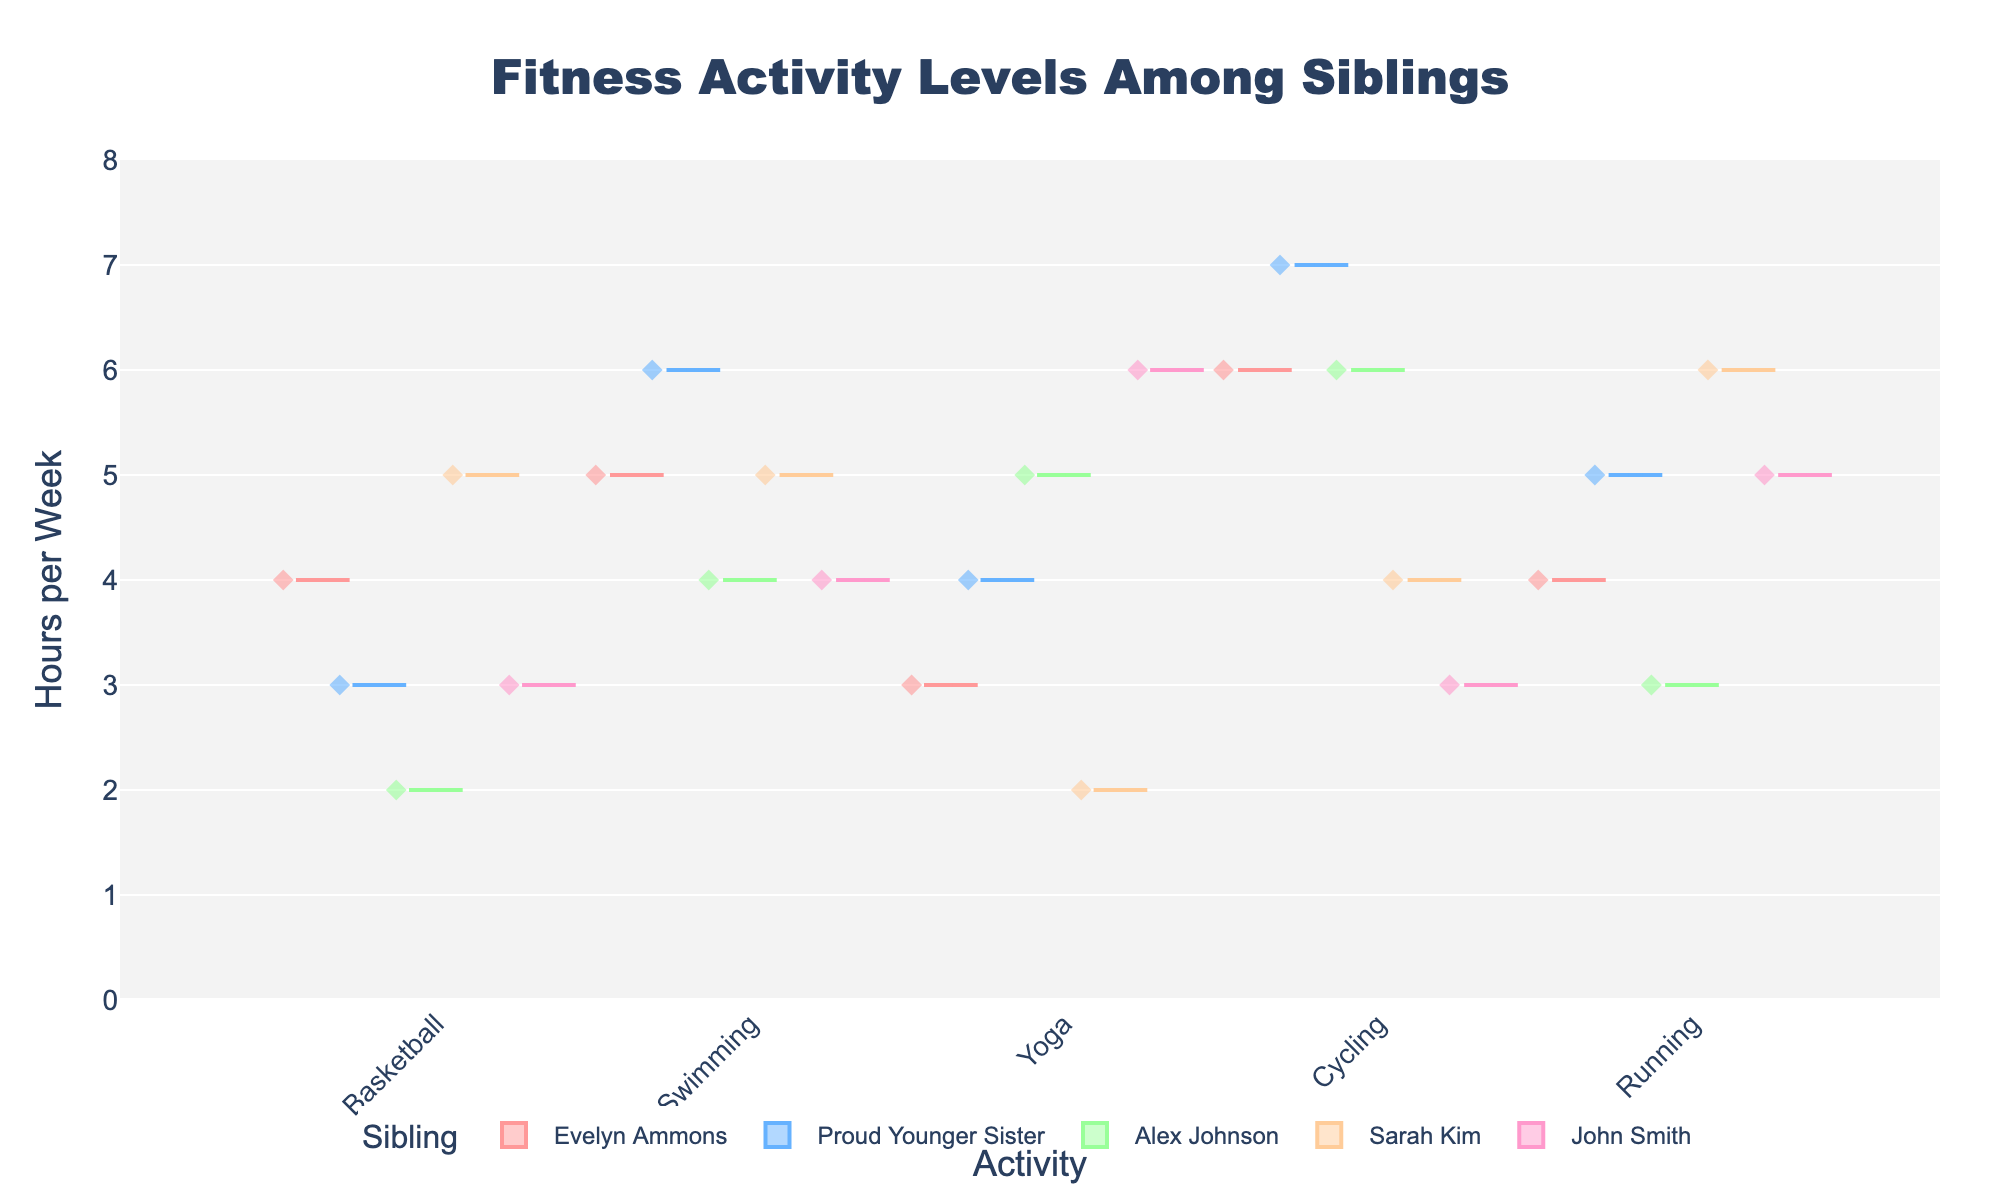Which sibling recorded the highest number of hours per week in Cycling? Look at the Violin Chart and identify the sibling with the longest specific plot for Cycling in hours per week. Proud Younger Sister has 7 hours of Cycling per week, which is the highest in the chart.
Answer: Proud Younger Sister How many hours per week does Evelyn spend on Swimming? Locate Evelyn Ammons on the violin plot under the Swimming category. She is shown to contribute 5 hours per week.
Answer: 5 Which activity did John Smith spend the least hours on per week? Check John Smith's data points for the minimum value across all activities: Basketball (3), Swimming (4), Yoga (6), Cycling (3), and Running (5). Cycling and Basketball both have 3 hours, the smallest number.
Answer: Cycling and Basketball What’s the range of hours per week that Alex Johnson spends on activities? Review the maximum and minimum hours Alex Johnson spent on various activities: 2 to 6 hours per week (the minimum is for Basketball and the maximum for Cycling and Swimming). The range is 6 - 2 = 4.
Answer: 4 Which two siblings have the same maximum hours per week for any activity, and what is that activity? Compare the maximum hours spent on a single activity for each sibling. Both John Smith and Alex Johnson have their maximum at 6 hours in Yoga and Cycling respectively.
Answer: John Smith, Alex Johnson, Yoga, Cycling Among all siblings, who has the highest overall hours per week in Running? Look at the Running category in the figure and check which sibling has the highest hours. Sarah Kim leads with 6 hours per week.
Answer: Sarah Kim Compare the median hours per week Evelyn and Proud Younger Sister spend on Basketball. Review the box plots for Evelyn Ammons and Proud Younger Sister under the Basketball section; the median for Evelyn Ammons is 4 and for Proud Younger Sister is 3.
Answer: Evelyn Ammons's median is higher Which activity shows the most variation for Sarah Kim? For Sarah Kim, look at the spread width of each violin plot and find the one with the largest spread. Yoga shows the most variation with hours spanning from 2 upwards.
Answer: Yoga In which activity is the average number of hours per week the same for both Evelyn Ammons and John Smith? Look at the mean lines in the box plot for various activities for both Evelyn Ammons and John Smith; in Swimming, both have an average around 4 hours.
Answer: Swimming How many siblings participate in Basketball based on the plots? Count the different siblings on the x-axis section labelled Basketball; each sibling is represented once. There are five siblings shown in Basketball.
Answer: Five 